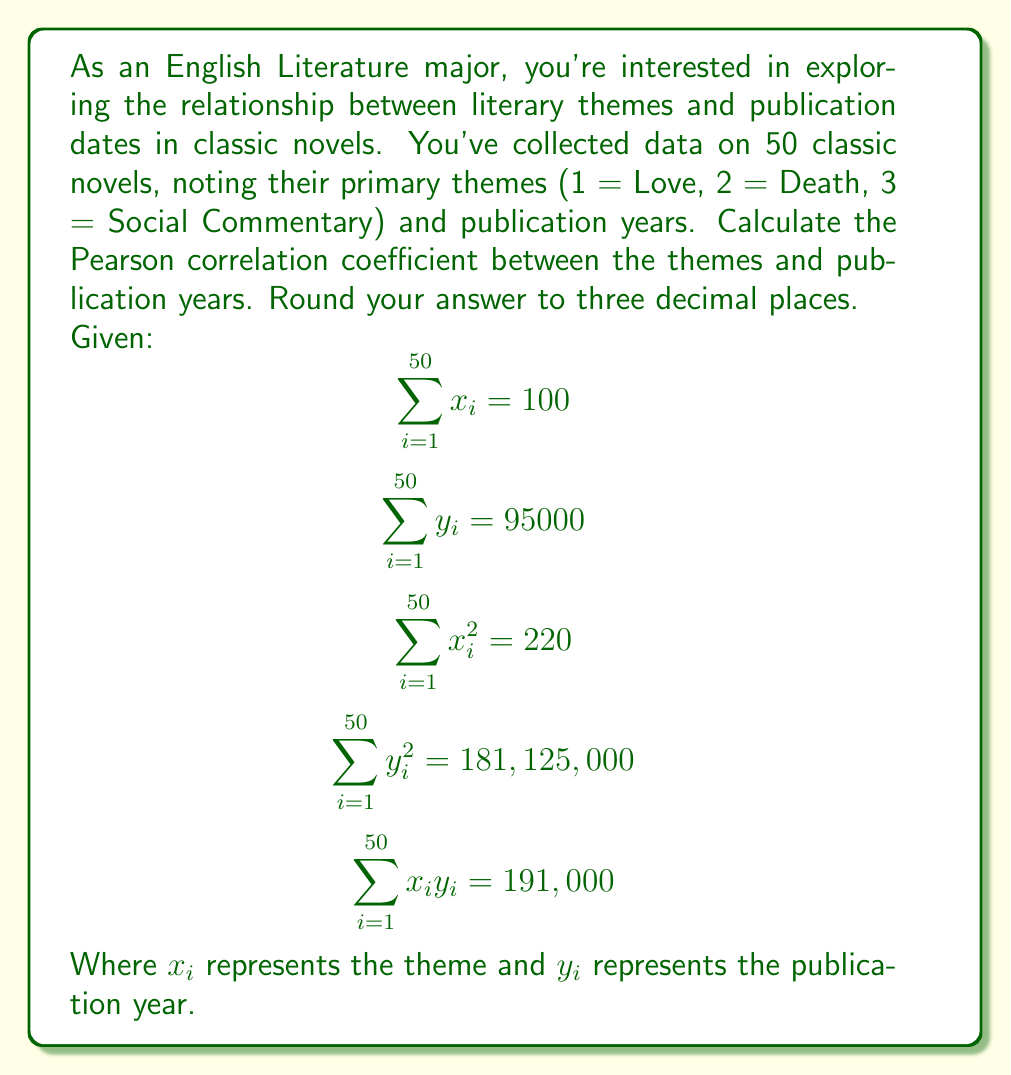Provide a solution to this math problem. To calculate the Pearson correlation coefficient, we'll use the formula:

$$r = \frac{n\sum x_iy_i - \sum x_i \sum y_i}{\sqrt{[n\sum x_i^2 - (\sum x_i)^2][n\sum y_i^2 - (\sum y_i)^2]}}$$

Where $n$ is the number of observations (50 in this case).

Let's calculate each part step by step:

1. $n\sum x_iy_i = 50 \times 191,000 = 9,550,000$

2. $\sum x_i \sum y_i = 100 \times 95,000 = 9,500,000$

3. $n\sum x_i^2 = 50 \times 220 = 11,000$

4. $(\sum x_i)^2 = 100^2 = 10,000$

5. $n\sum y_i^2 = 50 \times 181,125,000 = 9,056,250,000$

6. $(\sum y_i)^2 = 95,000^2 = 9,025,000,000$

Now, let's plug these values into the formula:

$$r = \frac{9,550,000 - 9,500,000}{\sqrt{(11,000 - 10,000)(9,056,250,000 - 9,025,000,000)}}$$

$$r = \frac{50,000}{\sqrt{1,000 \times 31,250,000}}$$

$$r = \frac{50,000}{\sqrt{31,250,000,000}}$$

$$r = \frac{50,000}{176,776.695}$$

$$r \approx 0.282847$$

Rounding to three decimal places, we get 0.283.
Answer: 0.283 